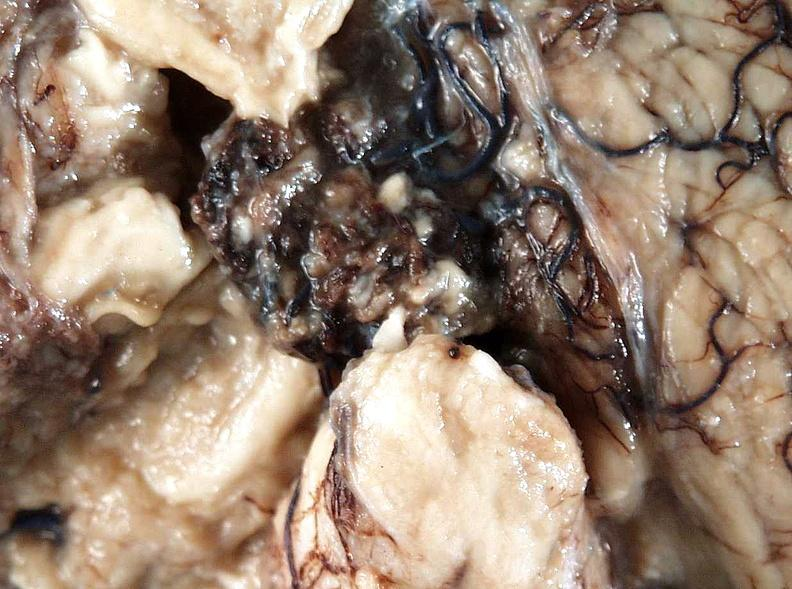does this fixed tissue show brain, cryptococcal meningitis?
Answer the question using a single word or phrase. No 